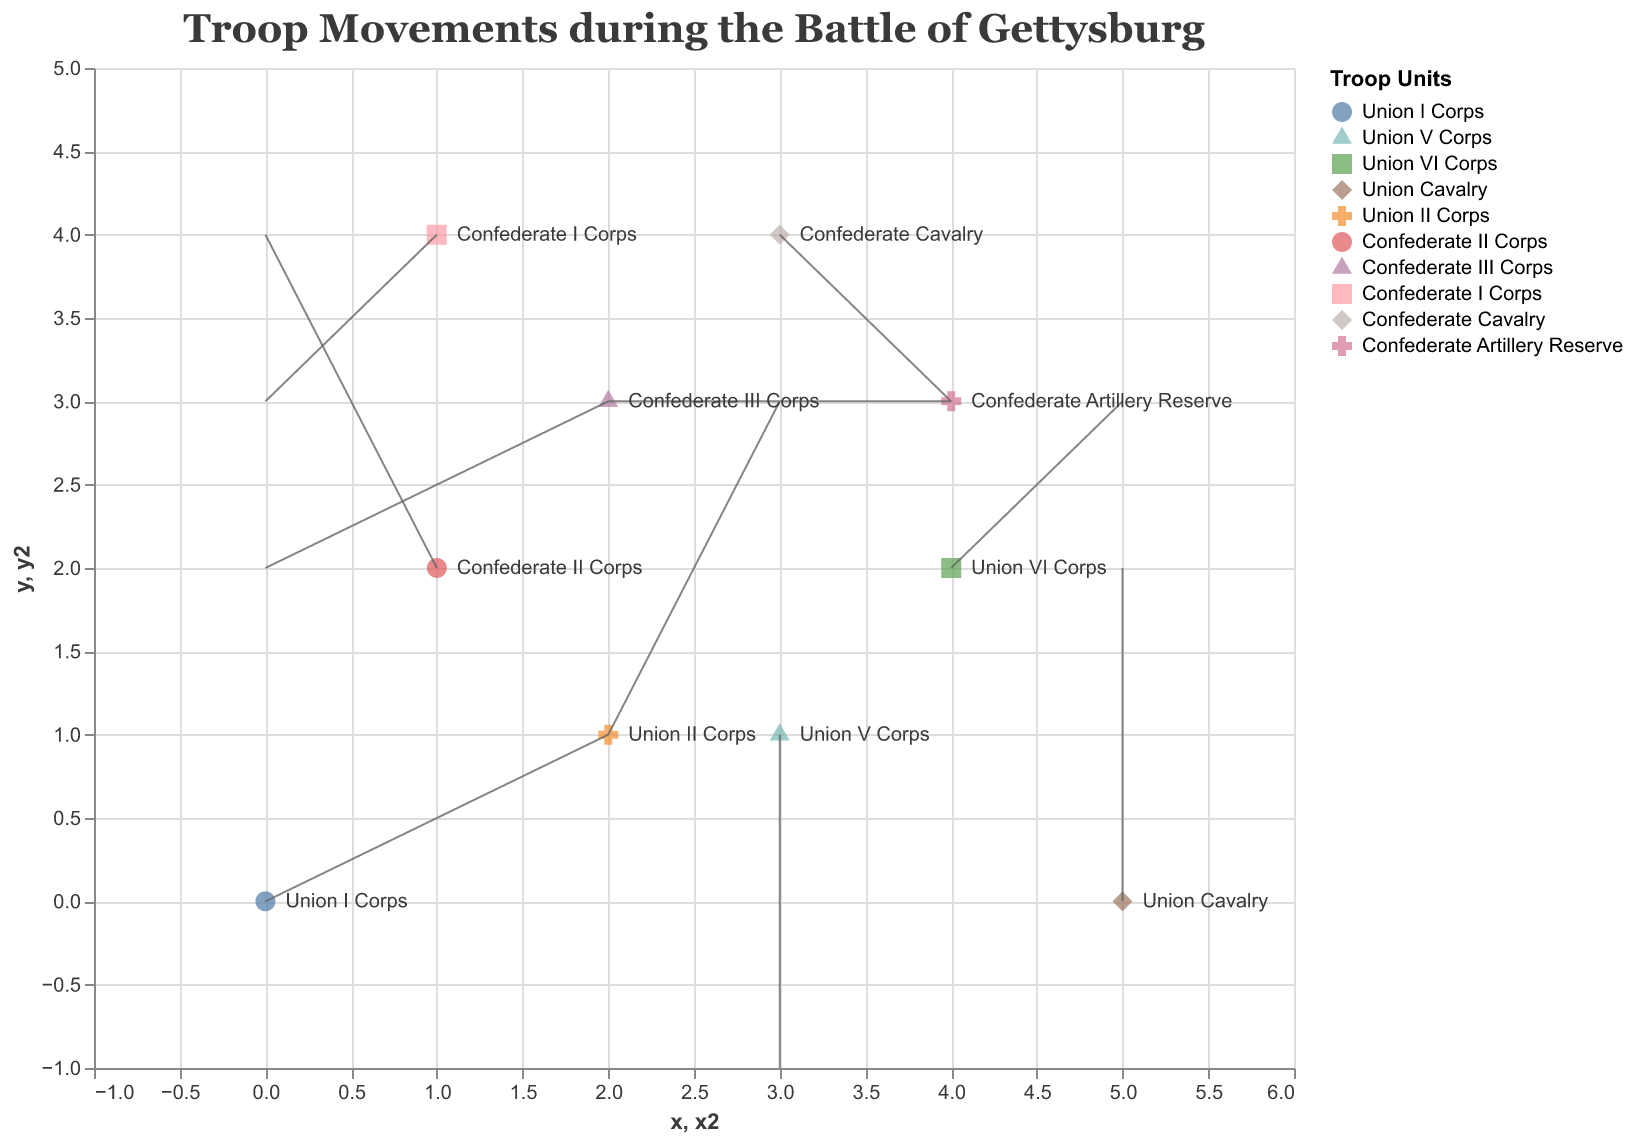What is the title of the figure? The title of the figure is usually displayed at the top of the chart. It provides a brief description of what the chart represents. In this case, the title indicates that the chart shows troop movements during the Battle of Gettysburg.
Answer: Troop Movements during the Battle of Gettysburg Which troop unit is located at coordinates (0, 0)? To determine which troop unit is at coordinates (0, 0), look at the points plotted on the graph. The label next to the point at (0, 0) shows which unit it represents.
Answer: Union I Corps What direction is the Union V Corps moving? The Union V Corps started at coordinates (3, 1). The change vectors for this unit are displayed as u = 0 and v = -2. This means it is moving vertically downwards without any horizontal change.
Answer: Downwards Which troop unit shows no vertical movement? Troop units with no vertical movement will have a v value of 0. In the data provided, "Confederate Artillery Reserve" has v = 0.
Answer: Confederate Artillery Reserve How far does the Confederate II Corps move in total? The movement of the Confederate II Corps is represented by the u and v values. The values are u = -1 and v = 2. To find the total movement, use the formula for the magnitude of the vector sqrt(u^2 + v^2). Therefore, the distance is sqrt((-1)^2 + (2)^2) = sqrt(1 + 4) = sqrt(5) ≈ 2.24.
Answer: Approximately 2.24 units Which units show diagonal movement? A diagonal movement implies that both u and v are non-zero (neither strictly horizontal nor vertical). By inspecting the data, Union II Corps (u = 1, v = 2), Confederate Cavalry (u = 1, v = -1), Confederate II Corps (u = -1, v = 2), and Union VI Corps (u = 1, v = 1) display diagonal movements.
Answer: Union II Corps, Confederate Cavalry, Confederate II Corps, Union VI Corps How many different unique starting points were there for all troop units? Look at the coordinates (x, y) of each troop unit. Removing duplicates from these coordinates reveals the unique starting positions.
Answer: 9 